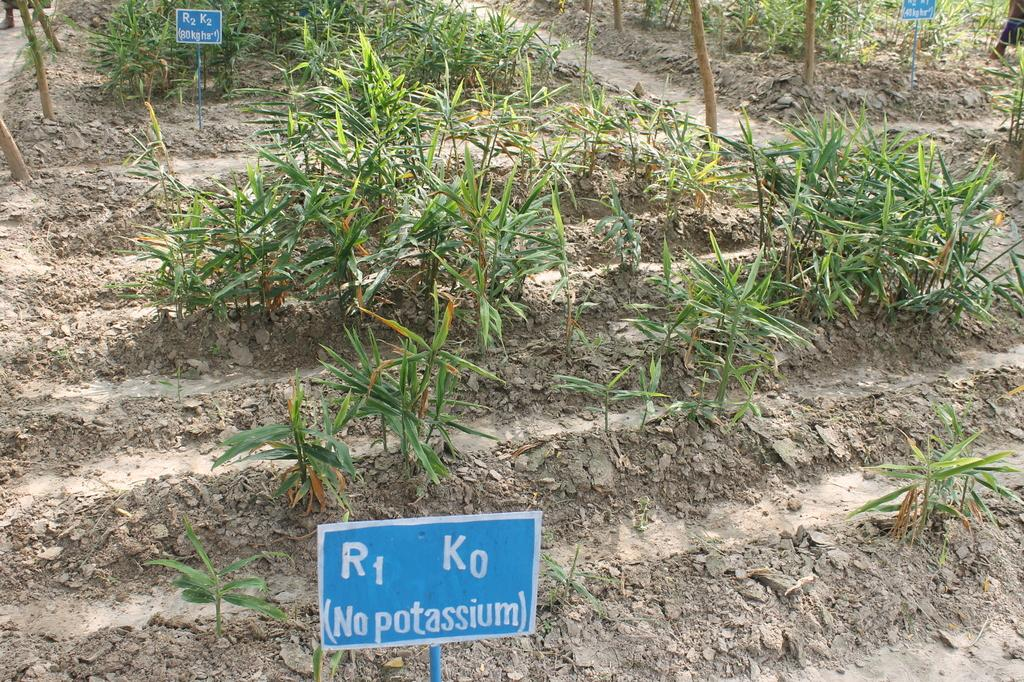What type of living organisms can be seen on the ground in the image? There are plants on the ground in the image. What is the color of the board in the image? The board in the image is blue. What is written or displayed on the blue color board? There is text on the blue color board. Can you tell me how many oranges are placed in the basket in the image? There is no basket or oranges present in the image. What type of arch can be seen in the background of the image? There is no arch visible in the image. 